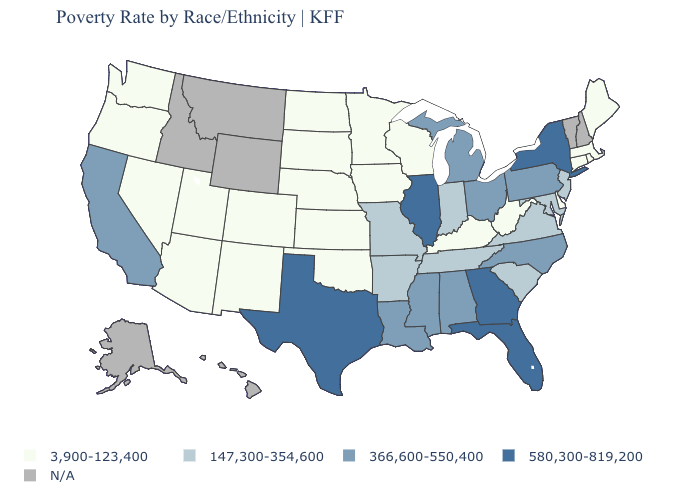Does Massachusetts have the highest value in the USA?
Give a very brief answer. No. Does Connecticut have the lowest value in the USA?
Concise answer only. Yes. Does the first symbol in the legend represent the smallest category?
Quick response, please. Yes. Name the states that have a value in the range 3,900-123,400?
Keep it brief. Arizona, Colorado, Connecticut, Delaware, Iowa, Kansas, Kentucky, Maine, Massachusetts, Minnesota, Nebraska, Nevada, New Mexico, North Dakota, Oklahoma, Oregon, Rhode Island, South Dakota, Utah, Washington, West Virginia, Wisconsin. What is the value of Hawaii?
Write a very short answer. N/A. Name the states that have a value in the range 147,300-354,600?
Be succinct. Arkansas, Indiana, Maryland, Missouri, New Jersey, South Carolina, Tennessee, Virginia. Which states have the lowest value in the Northeast?
Quick response, please. Connecticut, Maine, Massachusetts, Rhode Island. What is the value of Washington?
Be succinct. 3,900-123,400. Which states have the highest value in the USA?
Keep it brief. Florida, Georgia, Illinois, New York, Texas. Name the states that have a value in the range N/A?
Answer briefly. Alaska, Hawaii, Idaho, Montana, New Hampshire, Vermont, Wyoming. Does the map have missing data?
Give a very brief answer. Yes. What is the value of Maryland?
Give a very brief answer. 147,300-354,600. 